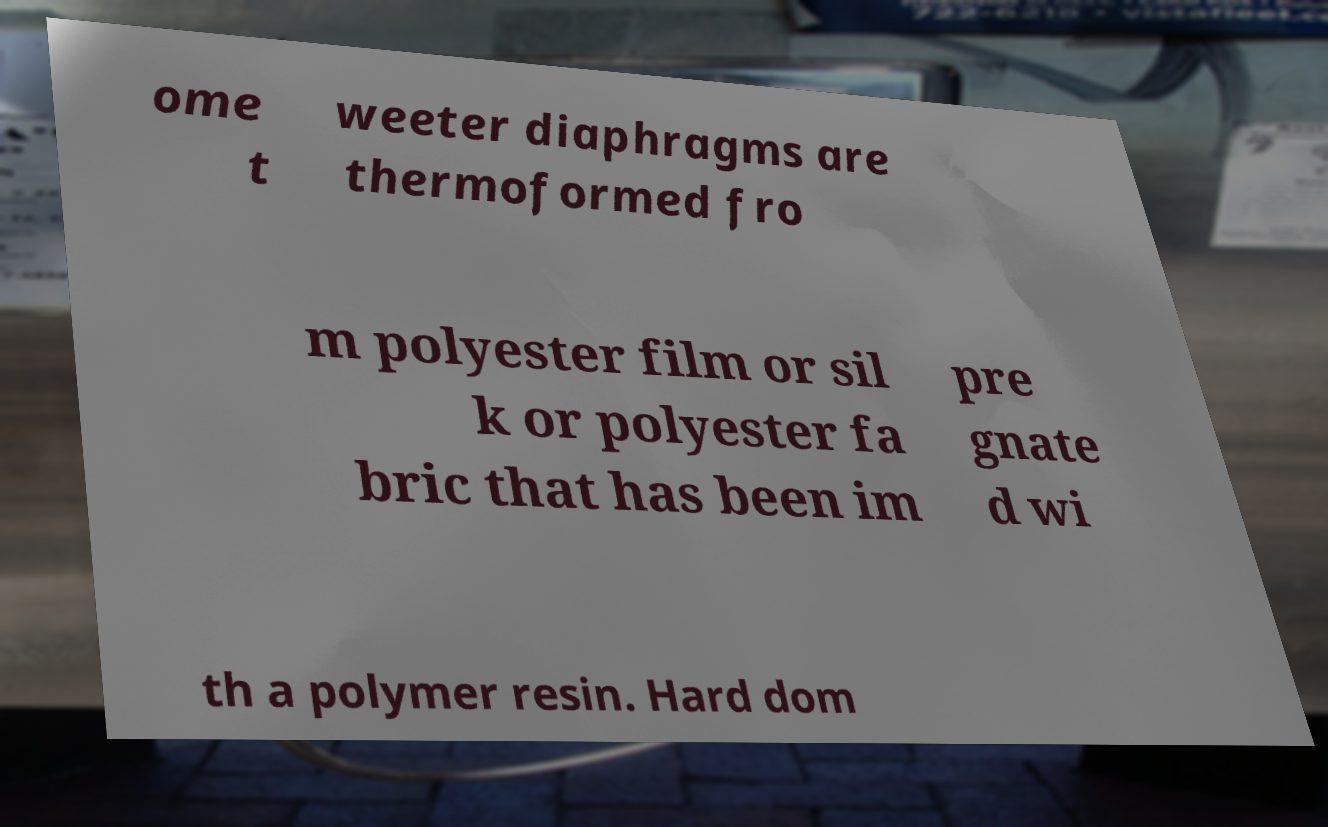Can you read and provide the text displayed in the image?This photo seems to have some interesting text. Can you extract and type it out for me? ome t weeter diaphragms are thermoformed fro m polyester film or sil k or polyester fa bric that has been im pre gnate d wi th a polymer resin. Hard dom 